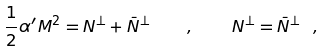<formula> <loc_0><loc_0><loc_500><loc_500>\frac { 1 } { 2 } \alpha ^ { \prime } M ^ { 2 } = N ^ { \perp } + \bar { N } ^ { \perp } \quad , \quad N ^ { \perp } = \bar { N } ^ { \perp } \ ,</formula> 